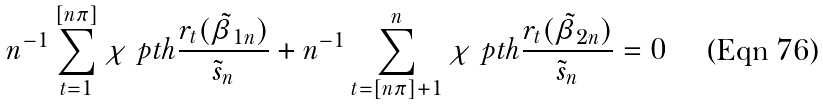<formula> <loc_0><loc_0><loc_500><loc_500>n ^ { - 1 } \sum ^ { [ n \pi ] } _ { t = 1 } \chi \ p t h { \frac { r _ { t } ( \tilde { \beta } _ { 1 n } ) } { \tilde { s } _ { n } } } + n ^ { - 1 } \sum _ { t = [ n \pi ] + 1 } ^ { n } \chi \ p t h { \frac { r _ { t } ( \tilde { \beta } _ { 2 n } ) } { \tilde { s } _ { n } } } = 0</formula> 